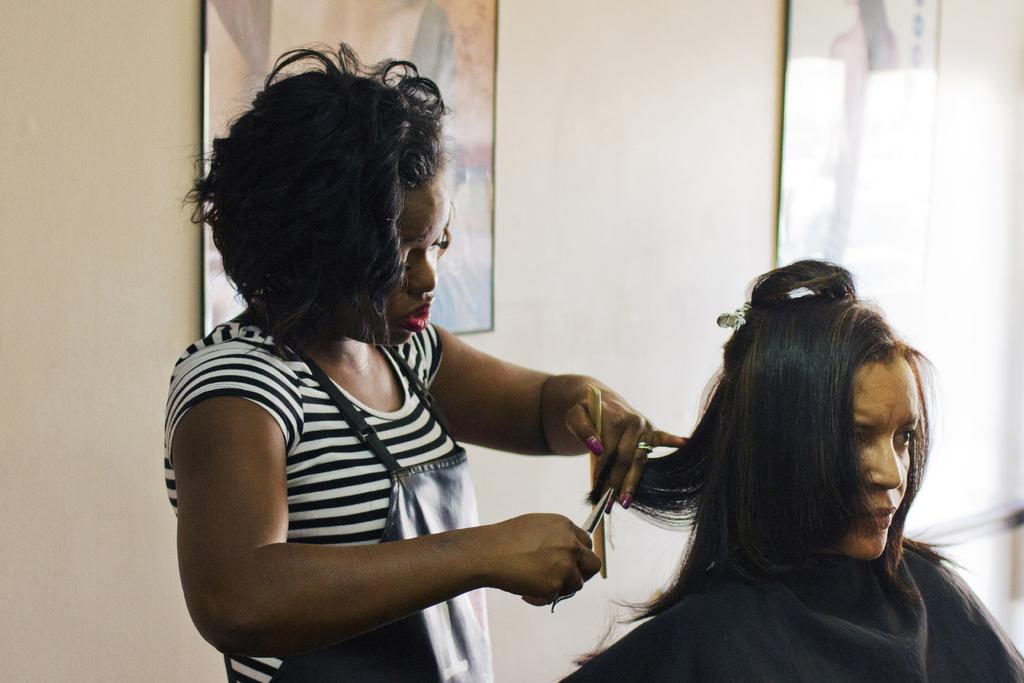What is the woman in the image doing? The woman is cutting the hair of another woman. What is the woman holding in her hands? The woman is holding a comb and a scissor. What is the position of the other woman in the image? The other woman is sitting on a chair. What can be seen on the wall in the background of the image? There are picture frames on a wall in the background of the image. What type of doll is sitting on the zebra in the image? There is no doll or zebra present in the image. How does the woman hold the grip while cutting the hair? The term "grip" is not mentioned in the facts provided, and there is no need to discuss how the woman holds the tools as it is not relevant to the main action in the image. 